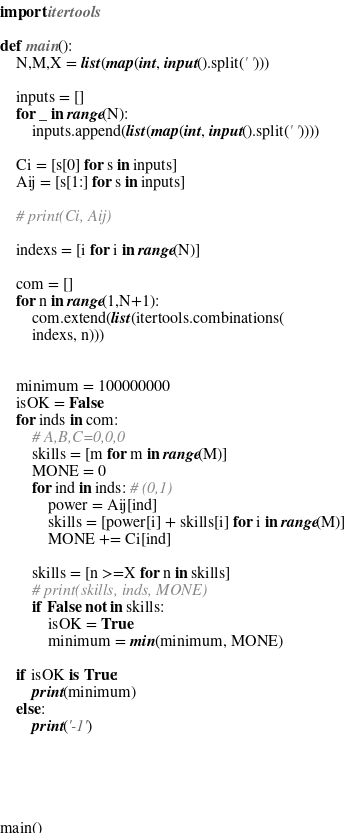<code> <loc_0><loc_0><loc_500><loc_500><_Python_>import itertools

def main():
    N,M,X = list(map(int, input().split(' ')))
    
    inputs = []
    for _ in range(N):
        inputs.append(list(map(int, input().split(' '))))
        
    Ci = [s[0] for s in inputs]
    Aij = [s[1:] for s in inputs]
    
    # print(Ci, Aij)
    
    indexs = [i for i in range(N)]
    
    com = []
    for n in range(1,N+1):
        com.extend(list(itertools.combinations(
        indexs, n)))
    
    
    minimum = 100000000
    isOK = False
    for inds in com:
        # A,B,C=0,0,0
        skills = [m for m in range(M)]
        MONE = 0
        for ind in inds: # (0,1)
            power = Aij[ind]
            skills = [power[i] + skills[i] for i in range(M)]
            MONE += Ci[ind]
        
        skills = [n >=X for n in skills]
        # print(skills, inds, MONE)
        if False not in skills:
            isOK = True
            minimum = min(minimum, MONE)
    
    if isOK is True:
        print(minimum)
    else:
        print('-1')
    
    
            
    

main()</code> 